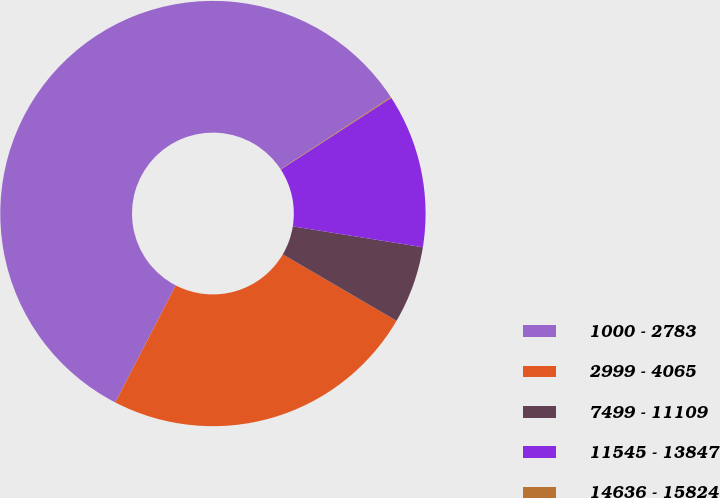<chart> <loc_0><loc_0><loc_500><loc_500><pie_chart><fcel>1000 - 2783<fcel>2999 - 4065<fcel>7499 - 11109<fcel>11545 - 13847<fcel>14636 - 15824<nl><fcel>58.18%<fcel>24.18%<fcel>5.88%<fcel>11.69%<fcel>0.07%<nl></chart> 